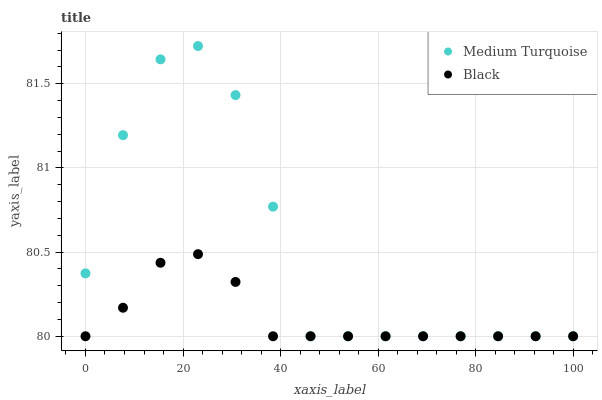Does Black have the minimum area under the curve?
Answer yes or no. Yes. Does Medium Turquoise have the maximum area under the curve?
Answer yes or no. Yes. Does Medium Turquoise have the minimum area under the curve?
Answer yes or no. No. Is Black the smoothest?
Answer yes or no. Yes. Is Medium Turquoise the roughest?
Answer yes or no. Yes. Is Medium Turquoise the smoothest?
Answer yes or no. No. Does Black have the lowest value?
Answer yes or no. Yes. Does Medium Turquoise have the highest value?
Answer yes or no. Yes. Does Medium Turquoise intersect Black?
Answer yes or no. Yes. Is Medium Turquoise less than Black?
Answer yes or no. No. Is Medium Turquoise greater than Black?
Answer yes or no. No. 